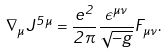<formula> <loc_0><loc_0><loc_500><loc_500>\nabla _ { \mu } J ^ { 5 \mu } = \frac { e ^ { 2 } } { 2 \pi } \frac { \epsilon ^ { \mu \nu } } { \sqrt { - g } } F _ { \mu \nu } . \label a { c h i r a l c u r r e n t a n o m a l y }</formula> 